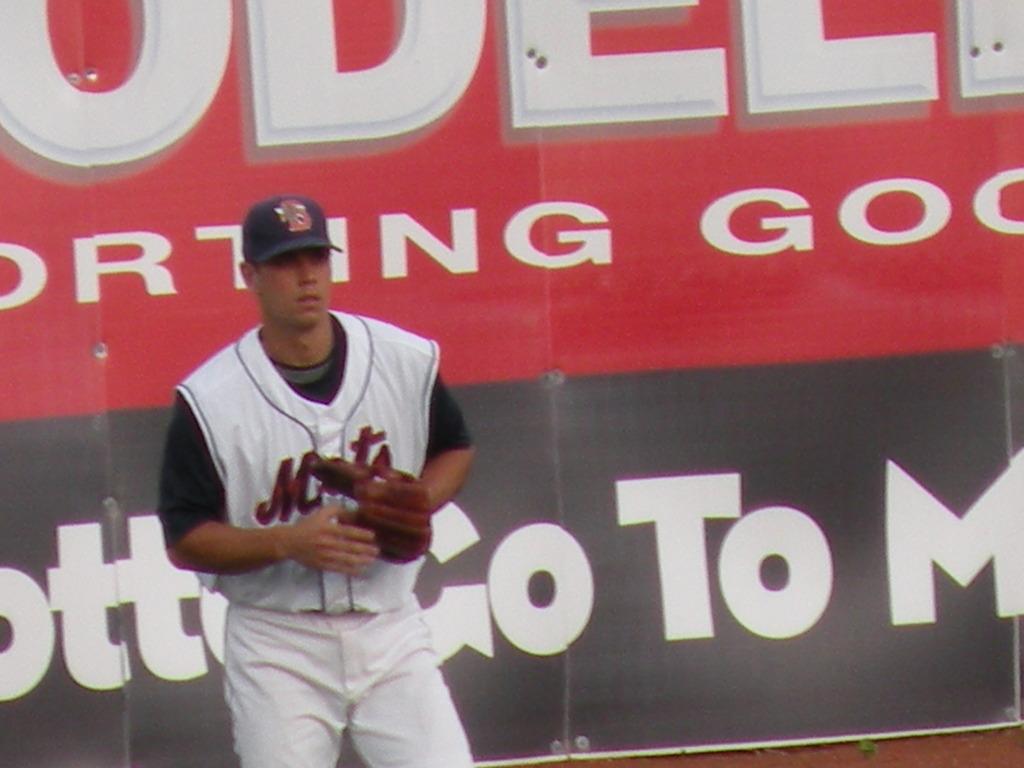What letter starts the word that is cut off on the bottom?
Your response must be concise. O. 